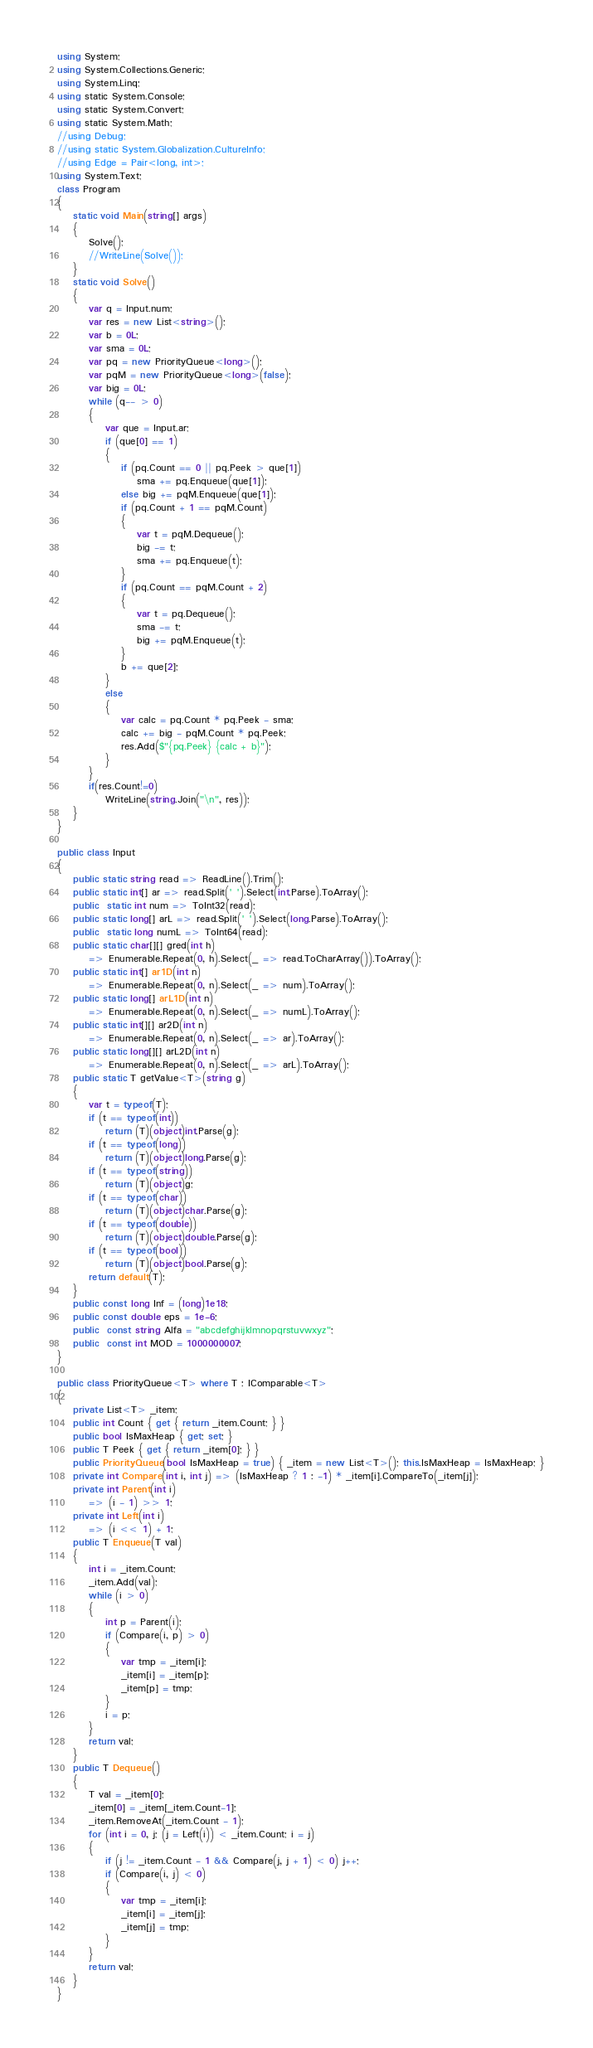<code> <loc_0><loc_0><loc_500><loc_500><_C#_>using System;
using System.Collections.Generic;
using System.Linq;
using static System.Console;
using static System.Convert;
using static System.Math;
//using Debug;
//using static System.Globalization.CultureInfo;
//using Edge = Pair<long, int>;
using System.Text;
class Program
{ 
    static void Main(string[] args)
    {
        Solve();
        //WriteLine(Solve());
    }
    static void Solve()
    {
        var q = Input.num;
        var res = new List<string>();
        var b = 0L;
        var sma = 0L;
        var pq = new PriorityQueue<long>();
        var pqM = new PriorityQueue<long>(false);
        var big = 0L;
        while (q-- > 0)
        {
            var que = Input.ar;
            if (que[0] == 1)
            {
                if (pq.Count == 0 || pq.Peek > que[1])
                    sma += pq.Enqueue(que[1]);
                else big += pqM.Enqueue(que[1]);
                if (pq.Count + 1 == pqM.Count)
                {
                    var t = pqM.Dequeue();
                    big -= t;
                    sma += pq.Enqueue(t);
                }
                if (pq.Count == pqM.Count + 2)
                {
                    var t = pq.Dequeue();
                    sma -= t;
                    big += pqM.Enqueue(t);
                }
                b += que[2];
            }
            else
            {
                var calc = pq.Count * pq.Peek - sma;
                calc += big - pqM.Count * pq.Peek;
                res.Add($"{pq.Peek} {calc + b}");
            }
        }
        if(res.Count!=0)
            WriteLine(string.Join("\n", res));
    }
}

public class Input
{
    public static string read => ReadLine().Trim();
    public static int[] ar => read.Split(' ').Select(int.Parse).ToArray();
    public  static int num => ToInt32(read);
    public static long[] arL => read.Split(' ').Select(long.Parse).ToArray();
    public  static long numL => ToInt64(read);
    public static char[][] gred(int h) 
        => Enumerable.Repeat(0, h).Select(_ => read.ToCharArray()).ToArray();
    public static int[] ar1D(int n)
        => Enumerable.Repeat(0, n).Select(_ => num).ToArray();
    public static long[] arL1D(int n)
        => Enumerable.Repeat(0, n).Select(_ => numL).ToArray();
    public static int[][] ar2D(int n)
        => Enumerable.Repeat(0, n).Select(_ => ar).ToArray();
    public static long[][] arL2D(int n)
        => Enumerable.Repeat(0, n).Select(_ => arL).ToArray();
    public static T getValue<T>(string g)
    {
        var t = typeof(T);
        if (t == typeof(int))
            return (T)(object)int.Parse(g);
        if (t == typeof(long))
            return (T)(object)long.Parse(g);
        if (t == typeof(string))
            return (T)(object)g;
        if (t == typeof(char))
            return (T)(object)char.Parse(g);
        if (t == typeof(double))
            return (T)(object)double.Parse(g);
        if (t == typeof(bool))
            return (T)(object)bool.Parse(g);
        return default(T);
    }
    public const long Inf = (long)1e18;
    public const double eps = 1e-6;
    public  const string Alfa = "abcdefghijklmnopqrstuvwxyz";
    public  const int MOD = 1000000007;
}

public class PriorityQueue<T> where T : IComparable<T>
{
    private List<T> _item;
    public int Count { get { return _item.Count; } }
    public bool IsMaxHeap { get; set; }
    public T Peek { get { return _item[0]; } }
    public PriorityQueue(bool IsMaxHeap = true) { _item = new List<T>(); this.IsMaxHeap = IsMaxHeap; }
    private int Compare(int i, int j) => (IsMaxHeap ? 1 : -1) * _item[i].CompareTo(_item[j]);
    private int Parent(int i)
        => (i - 1) >> 1;
    private int Left(int i)
        => (i << 1) + 1;
    public T Enqueue(T val)
    {
        int i = _item.Count;
        _item.Add(val);
        while (i > 0)
        {
            int p = Parent(i);
            if (Compare(i, p) > 0)
            {
                var tmp = _item[i];
                _item[i] = _item[p];
                _item[p] = tmp;
            }
            i = p;
        }
        return val;
    }
    public T Dequeue()
    {
        T val = _item[0];
        _item[0] = _item[_item.Count-1];
        _item.RemoveAt(_item.Count - 1);
        for (int i = 0, j; (j = Left(i)) < _item.Count; i = j)
        {
            if (j != _item.Count - 1 && Compare(j, j + 1) < 0) j++;
            if (Compare(i, j) < 0)
            {
                var tmp = _item[i];
                _item[i] = _item[j];
                _item[j] = tmp;
            }
        }
        return val;
    }
}
</code> 